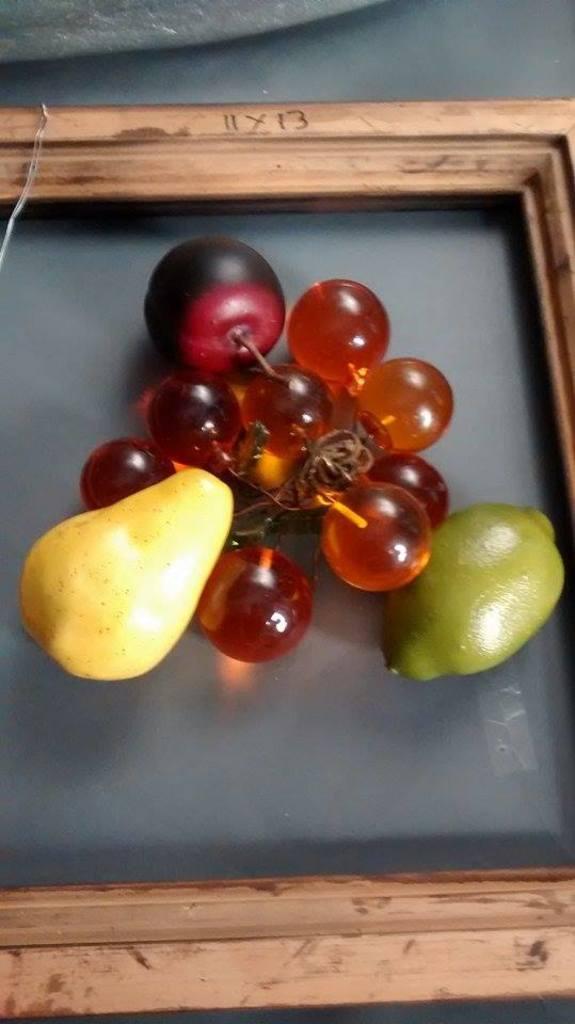In one or two sentences, can you explain what this image depicts? In this image we can see a tray. In the tray there are fruits. 